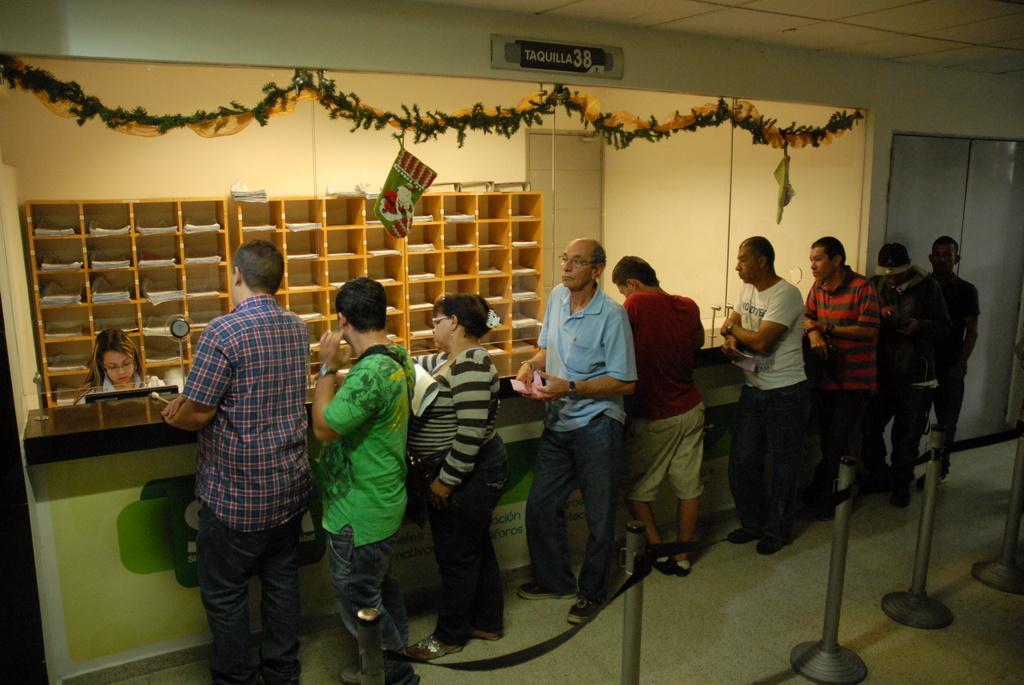How would you summarize this image in a sentence or two? There are few people standing in a queue. Here is the woman sitting. These are the racks with the papers in it. These look like the decorative items. On the right side of the image, that looks like a door. These look like the rope barriers, which are on the floor. 